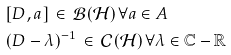<formula> <loc_0><loc_0><loc_500><loc_500>[ & D , a ] \, \in \, { \mathcal { B } } ( { \mathcal { H } } ) \, \forall a \in A \\ ( & D - \lambda ) ^ { - 1 } \, \in \, { \mathcal { C } } ( { \mathcal { H } } ) \, \forall \lambda \in { \mathbb { C } } - { \mathbb { R } }</formula> 